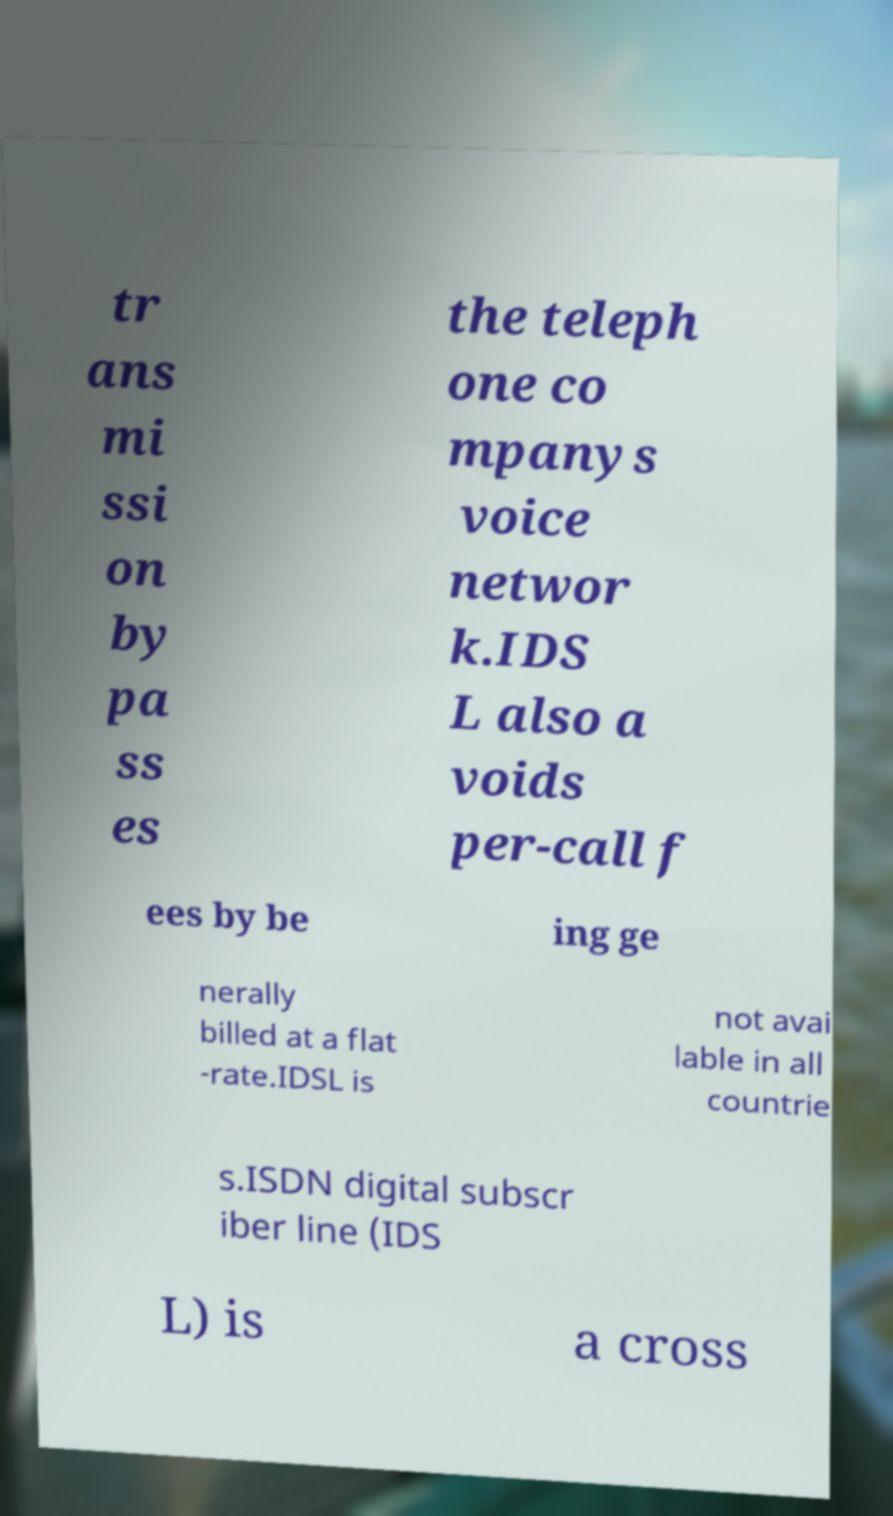Could you assist in decoding the text presented in this image and type it out clearly? tr ans mi ssi on by pa ss es the teleph one co mpanys voice networ k.IDS L also a voids per-call f ees by be ing ge nerally billed at a flat -rate.IDSL is not avai lable in all countrie s.ISDN digital subscr iber line (IDS L) is a cross 